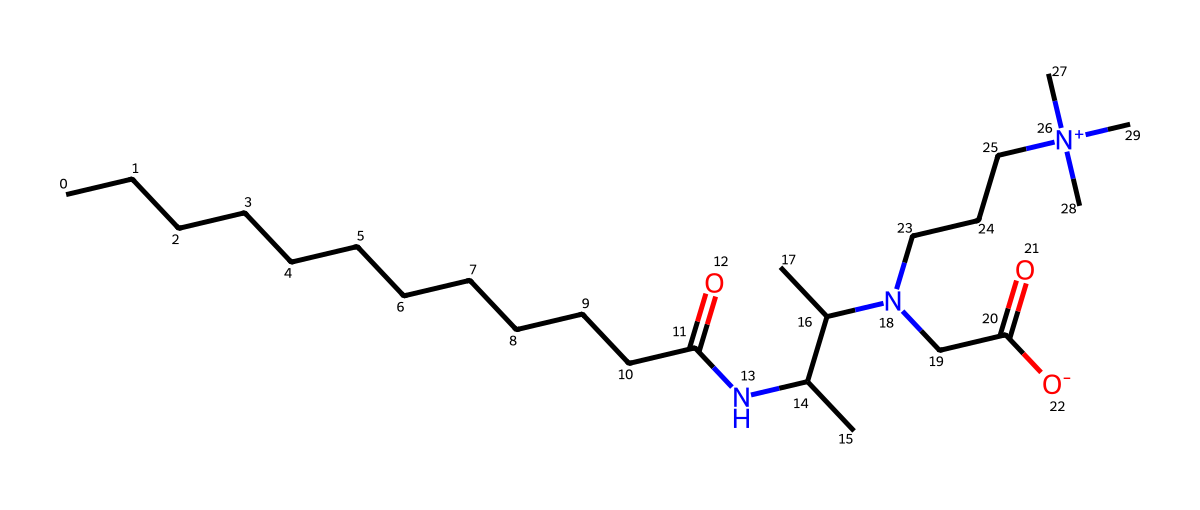What is the total number of carbon atoms in cocamidopropyl betaine? By analyzing the SMILES representation, I identify the carbon chains and functional groups. There are 20 carbon atoms present in the longest continuous chain and the branched methyl groups.
Answer: 20 How many nitrogen atoms are present in the structure? In the SMILES representation, I locate the 'N' symbols which indicate the presence of nitrogen atoms. There are a total of 3 nitrogen atoms in cocamidopropyl betaine.
Answer: 3 What functional group is indicated by the presence of "NC" in the SMILES? The "NC" portion of the structure indicates an amine group (where nitrogen is bonded to carbon), specifically a secondary amine due to the presence of aliphatic groups attached to the nitrogen atom.
Answer: amine Is cocamidopropyl betaine anionic, cationic, or amphoteric? The structure shows a positive charge on the nitrogen atom (indicated by "[N+](C)(C)C") and the presence of a carboxylate group (from "CC(=O)[O-]"), indicating that it can act as both a cation and an anion, thus classifying it as amphoteric.
Answer: amphoteric What type of surfactant is cocamidopropyl betaine classified as based on its structure? Based on the presence of both hydrophilic (polar) groups (the carboxylate and the positively charged nitrogen) and hydrophobic carbon chains, cocamidopropyl betaine is classified as a zwitterionic surfactant, a type of amphoteric surfactant.
Answer: zwitterionic Which part of the molecule contributes to its mild cleaning properties? The long hydrophobic carbon chain contributes to the detergent's ability to interact with oils and dirt, while the hydrophilic head groups provide solubility in water, allowing for effective cleaning without irritation.
Answer: hydrophobic carbon chain 